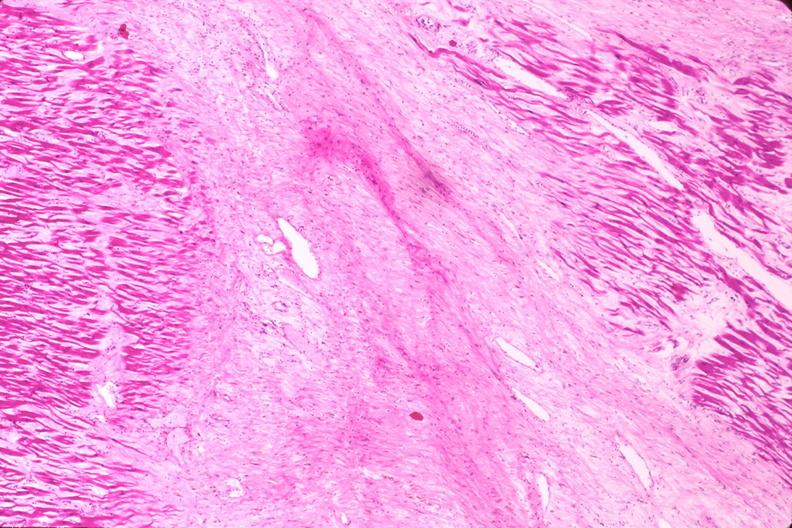where is this in?
Answer the question using a single word or phrase. In vasculature 